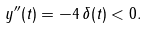<formula> <loc_0><loc_0><loc_500><loc_500>y ^ { \prime \prime } ( t ) = - 4 \, \delta ( t ) < 0 .</formula> 